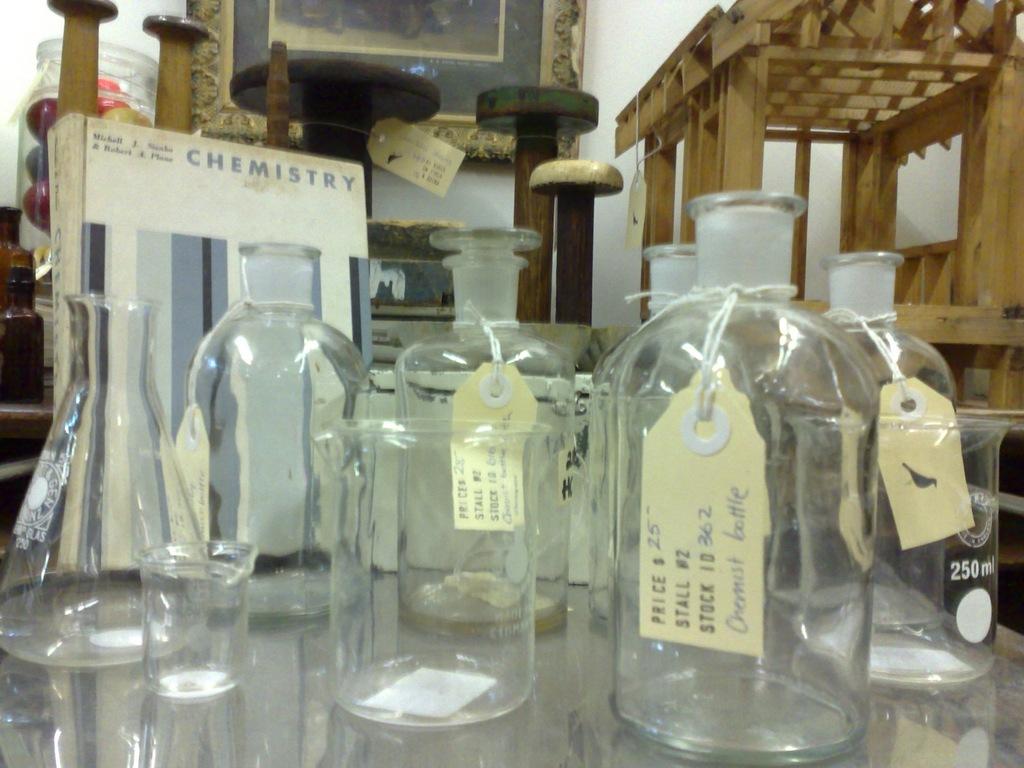What are the pieces of material used for?
Offer a very short reply. Chemistry. Is chemistry a glass company?
Make the answer very short. Yes. 